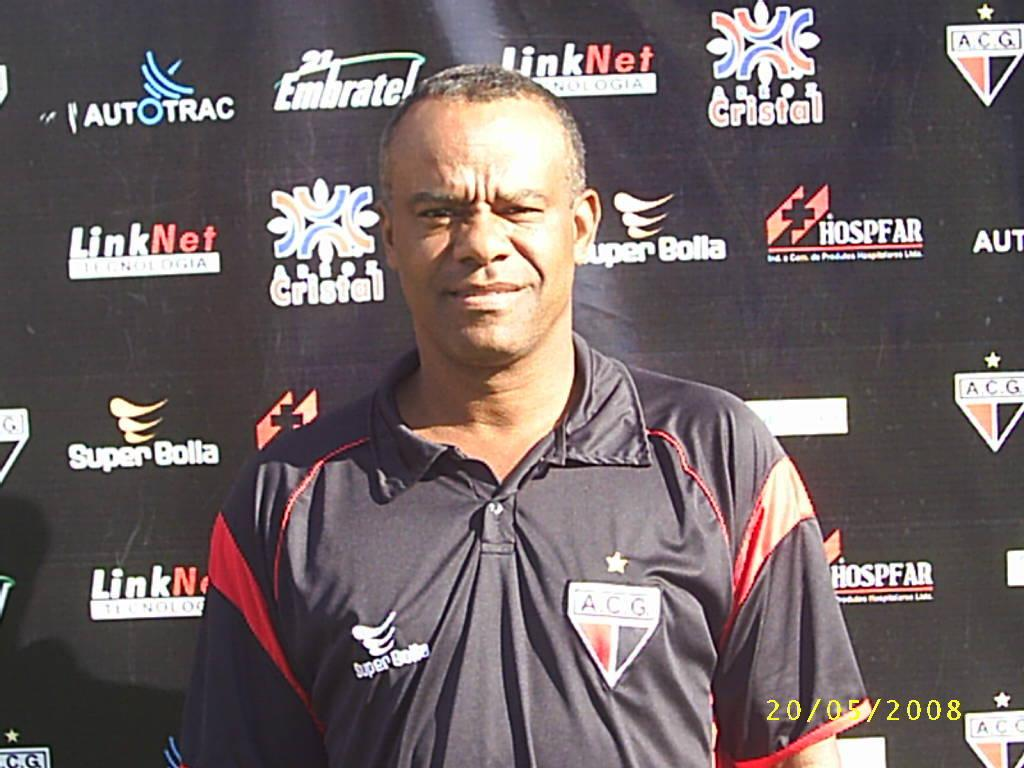<image>
Provide a brief description of the given image. A man in an ACG shirt stands in front of a display with multiple brand names written on it. 